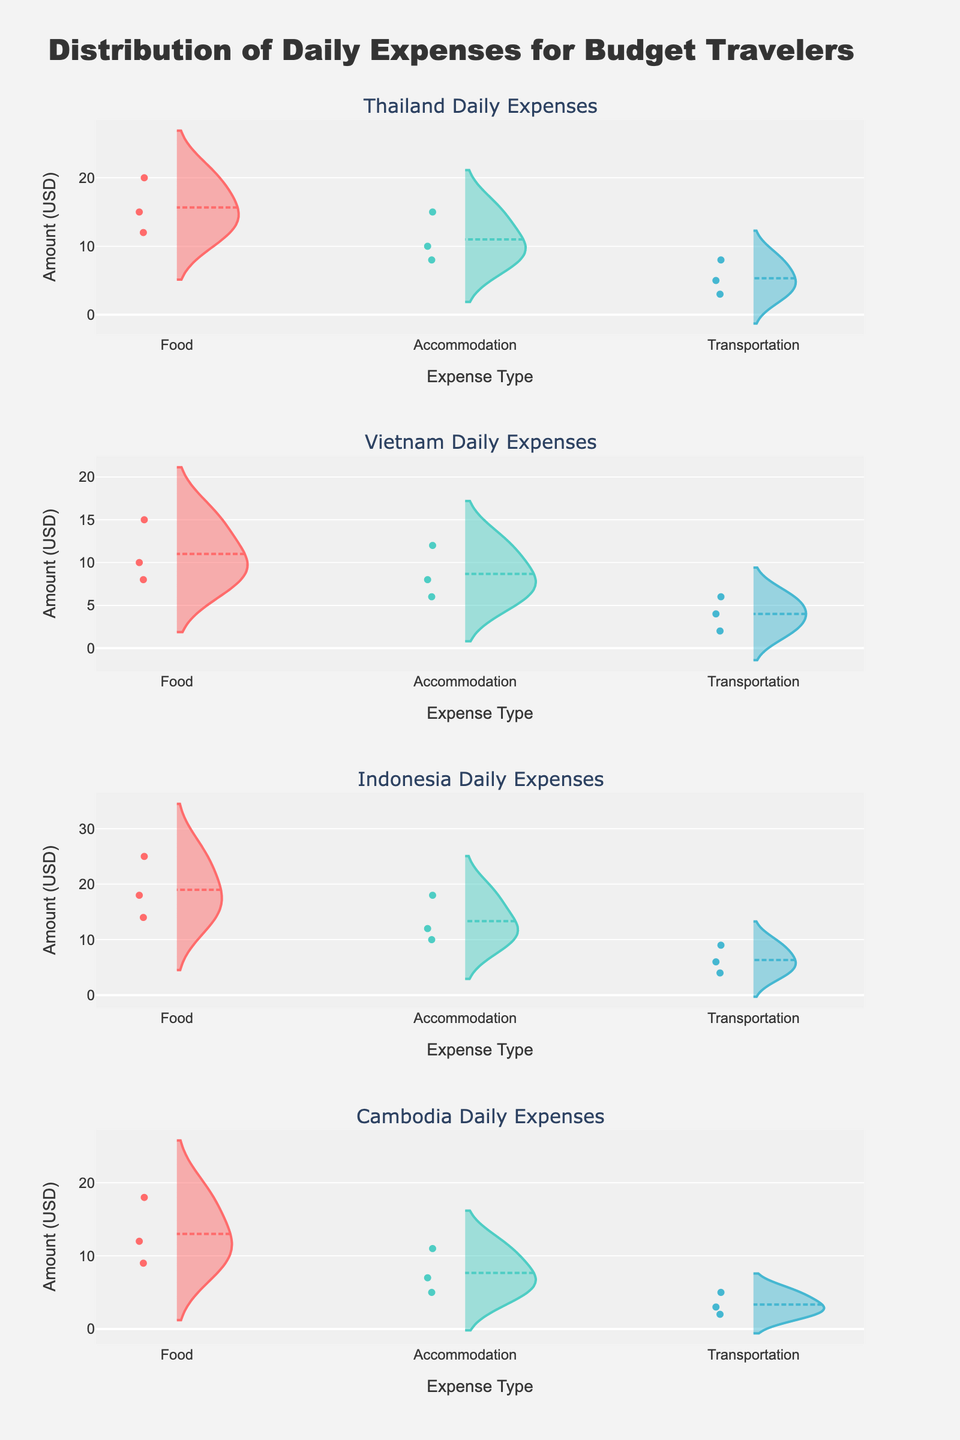Can you describe the overall title of the figure? The title is placed at the top of the figure and usually summarizes what the figure is about. In this case, it says, "Distribution of Daily Expenses for Budget Travelers," which indicates the main theme.
Answer: Distribution of Daily Expenses for Budget Travelers What types of expenses are shown for Thailand? The x-axis labels of the subplot for Thailand should list the expense types: Food, Accommodation, and Transportation. These are the categories of expenses analyzed for this country.
Answer: Food, Accommodation, Transportation Which country appears to have the highest range of daily food expenses? By comparing the range of amounts for food expenses across the different subplots, note which country's boxes and whiskers span the widest range. From this, it can be observed that Indonesia's food expense data ranges from 14 to 25 USD, which is wider than other countries.
Answer: Indonesia How does the median transportation expense in Vietnam compare to that in Cambodia? The median is usually represented by a horizontal line inside the box of each violin plot. Comparing the median transportation expenses for Vietnam and Cambodia, we find that Vietnam's median is higher (around 4 USD) compared to Cambodia's (around 3 USD).
Answer: Vietnam’s median is higher What is the distribution of accommodation expenses in Thailand? The accommodation expenses for Thailand show three distinct data points within the range of 8 to 15 USD. The density plot and marked points indicate how frequently each value appears.
Answer: 8 to 15 USD Which country's accommodation expenses show the smallest variability? Variability can be inferred by the density width and the spread of points. Cambodia's distribution is more compact for accommodation, with expenses lying between 5 and 11 USD, implying smaller variability.
Answer: Cambodia Which expense type generally shows the least amount spent across all countries? By comparing the lowest amounts in the Transportation expense category across the subplots for all countries, transportation generally shows the least amount spent, with the range from 2 to 9 USD.
Answer: Transportation What color represents food expenses across all countries? The color associated with food expense is consistent across subplots; it is typically the first (and usually distinct) color used. The food expense is represented by red color in the figure.
Answer: Red Are there any outliers in the transportation expenses for any country? Outliers are often points that fall far from the rest of the data within a category. Checking the transportation expenses across all subplots, no specific points appear significantly distanced from the rest of the data in any country.
Answer: No What can one infer about the transportation expenses in Indonesia based on the density plot? Indonesia's transportation expenses plot reveals a clustering around lower amounts, with a dense concentration between 4 and 6 USD, indicating it is common to consistently incur these costs.
Answer: Clustered between 4 and 6 USD 